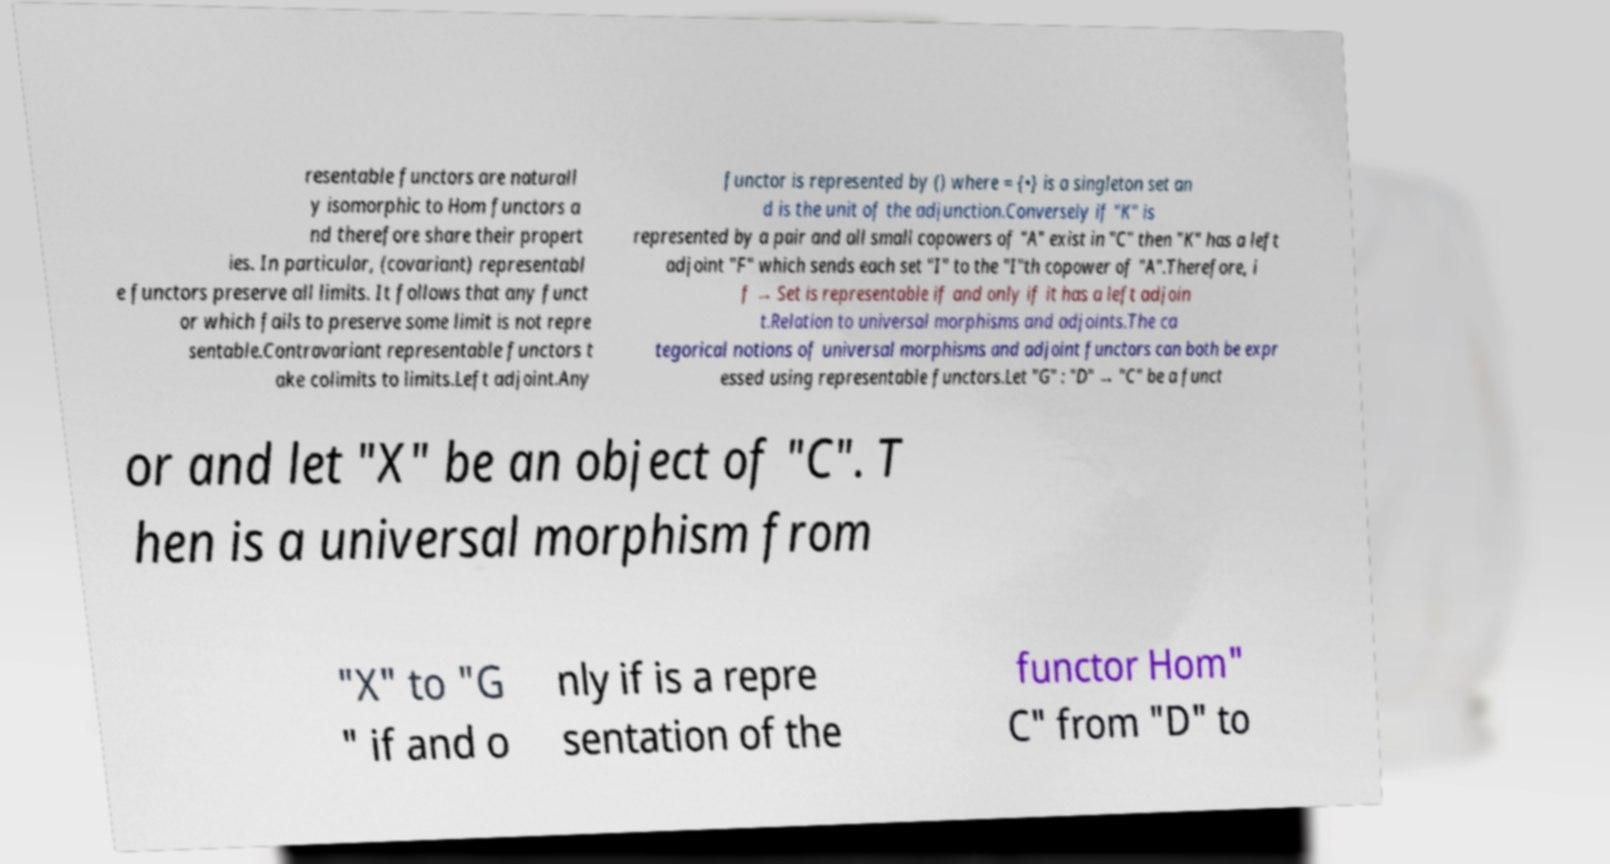Please identify and transcribe the text found in this image. resentable functors are naturall y isomorphic to Hom functors a nd therefore share their propert ies. In particular, (covariant) representabl e functors preserve all limits. It follows that any funct or which fails to preserve some limit is not repre sentable.Contravariant representable functors t ake colimits to limits.Left adjoint.Any functor is represented by () where = {•} is a singleton set an d is the unit of the adjunction.Conversely if "K" is represented by a pair and all small copowers of "A" exist in "C" then "K" has a left adjoint "F" which sends each set "I" to the "I"th copower of "A".Therefore, i f → Set is representable if and only if it has a left adjoin t.Relation to universal morphisms and adjoints.The ca tegorical notions of universal morphisms and adjoint functors can both be expr essed using representable functors.Let "G" : "D" → "C" be a funct or and let "X" be an object of "C". T hen is a universal morphism from "X" to "G " if and o nly if is a repre sentation of the functor Hom" C" from "D" to 